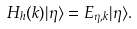<formula> <loc_0><loc_0><loc_500><loc_500>H _ { h } ( k ) | \eta \rangle = E _ { \eta , k } | \eta \rangle .</formula> 